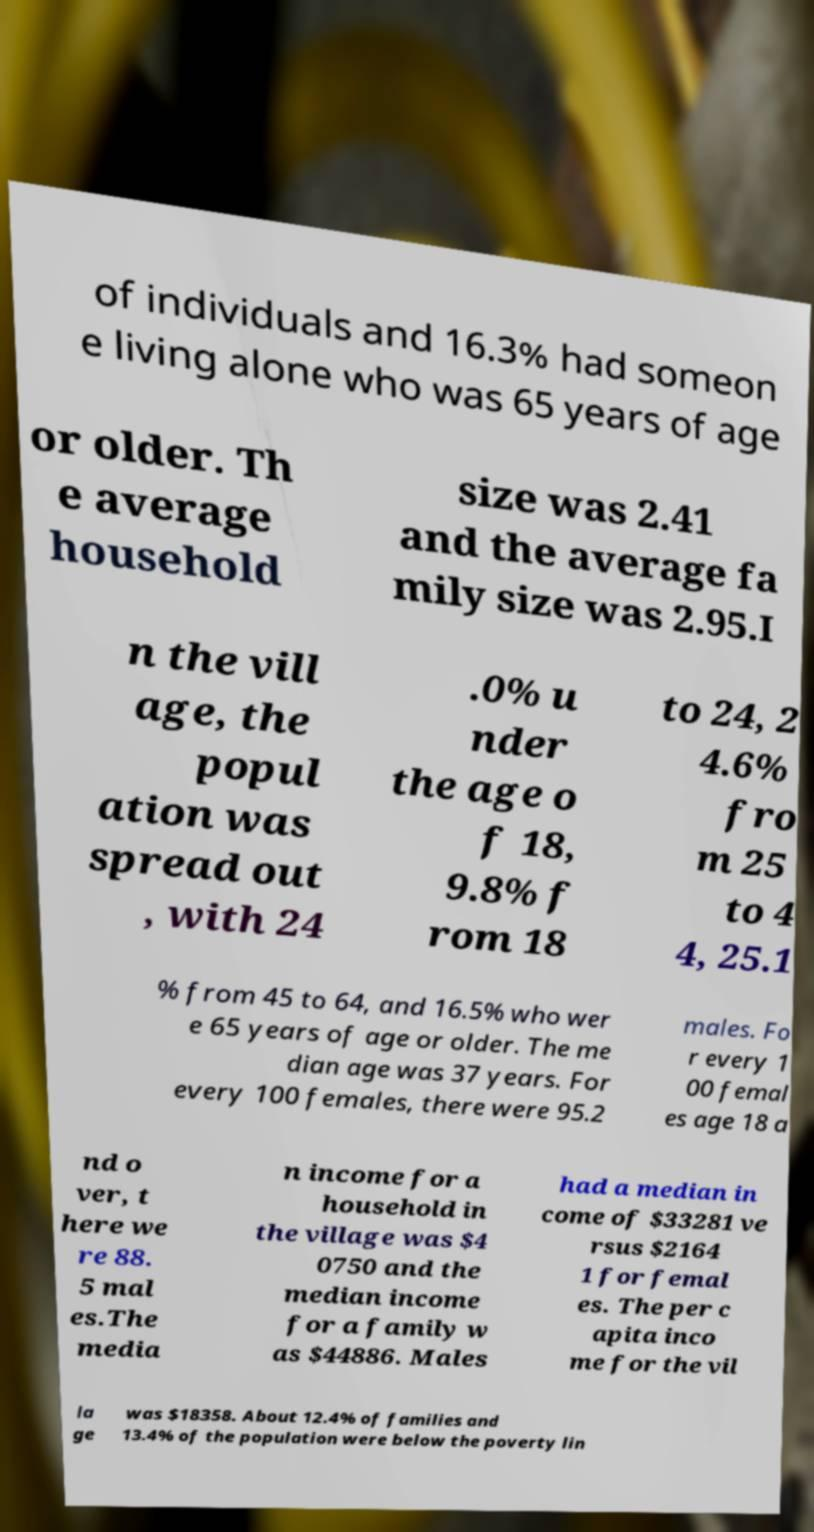Please identify and transcribe the text found in this image. of individuals and 16.3% had someon e living alone who was 65 years of age or older. Th e average household size was 2.41 and the average fa mily size was 2.95.I n the vill age, the popul ation was spread out , with 24 .0% u nder the age o f 18, 9.8% f rom 18 to 24, 2 4.6% fro m 25 to 4 4, 25.1 % from 45 to 64, and 16.5% who wer e 65 years of age or older. The me dian age was 37 years. For every 100 females, there were 95.2 males. Fo r every 1 00 femal es age 18 a nd o ver, t here we re 88. 5 mal es.The media n income for a household in the village was $4 0750 and the median income for a family w as $44886. Males had a median in come of $33281 ve rsus $2164 1 for femal es. The per c apita inco me for the vil la ge was $18358. About 12.4% of families and 13.4% of the population were below the poverty lin 